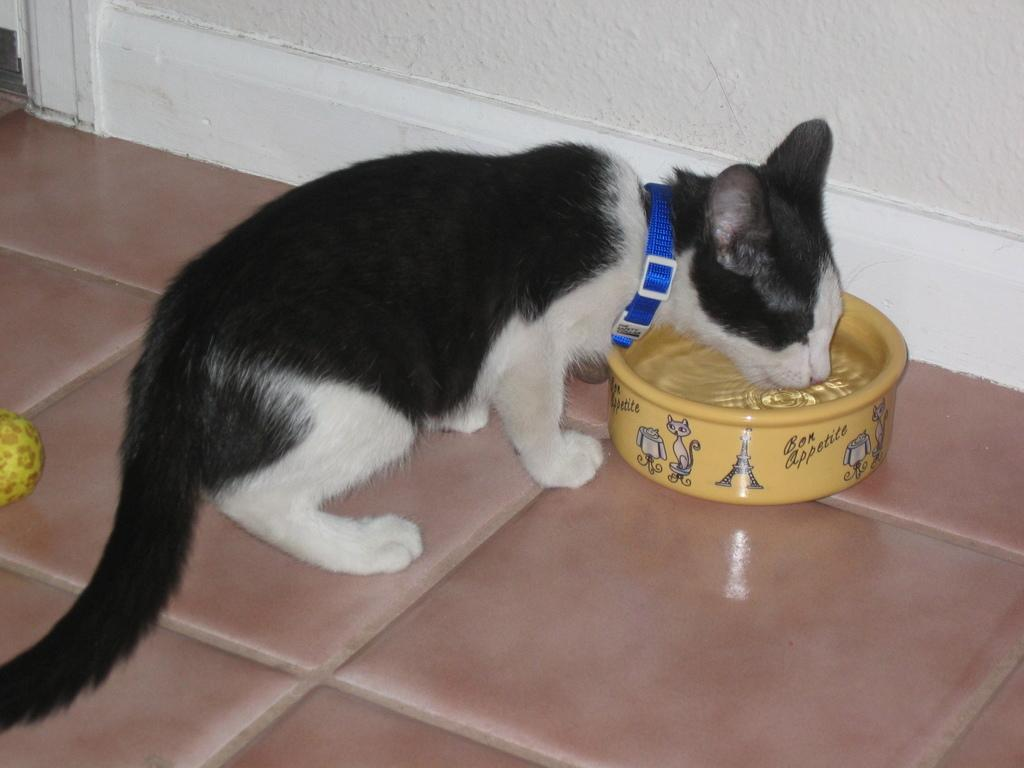What type of animal is in the image? There is a cat in the image. Can you describe the appearance of the cat? The cat is black and white in color. What is located in front of the cat? There is a yellow water bowl in front of the cat. What color is the wall behind the cat? The wall behind the cat is white in color. Is the cat involved in a fight with another animal in the image? No, there is no indication of a fight or any other animals present in the image. 